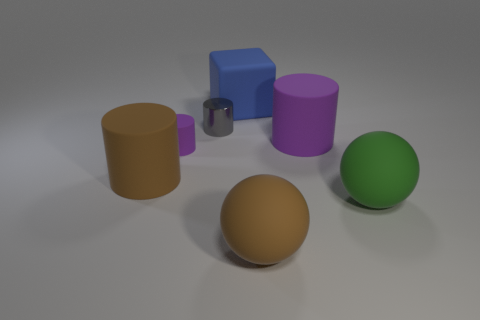What is the big block made of?
Your response must be concise. Rubber. There is a small cylinder in front of the large purple rubber object; is its color the same as the large cylinder on the left side of the big blue cube?
Provide a succinct answer. No. Are there more green matte objects left of the big brown rubber cylinder than blue matte things?
Your answer should be compact. No. How many other things are there of the same color as the big rubber cube?
Make the answer very short. 0. Do the cylinder that is on the right side of the brown matte sphere and the shiny cylinder have the same size?
Ensure brevity in your answer.  No. Is there a purple cylinder of the same size as the block?
Offer a terse response. Yes. What color is the large cylinder to the right of the gray thing?
Your answer should be very brief. Purple. What is the shape of the thing that is both behind the large purple rubber thing and on the left side of the big blue matte object?
Offer a terse response. Cylinder. What number of blue matte things are the same shape as the small gray shiny thing?
Your response must be concise. 0. How many tiny cyan shiny cylinders are there?
Give a very brief answer. 0. 